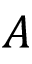<formula> <loc_0><loc_0><loc_500><loc_500>A</formula> 